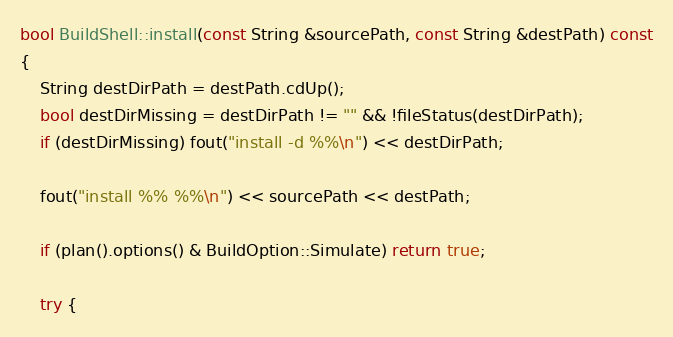<code> <loc_0><loc_0><loc_500><loc_500><_C++_>bool BuildShell::install(const String &sourcePath, const String &destPath) const
{
    String destDirPath = destPath.cdUp();
    bool destDirMissing = destDirPath != "" && !fileStatus(destDirPath);
    if (destDirMissing) fout("install -d %%\n") << destDirPath;

    fout("install %% %%\n") << sourcePath << destPath;

    if (plan().options() & BuildOption::Simulate) return true;

    try {</code> 